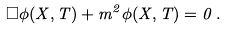<formula> <loc_0><loc_0><loc_500><loc_500>\Box \phi ( X , T ) + m ^ { 2 } \phi ( X , T ) = 0 \, .</formula> 